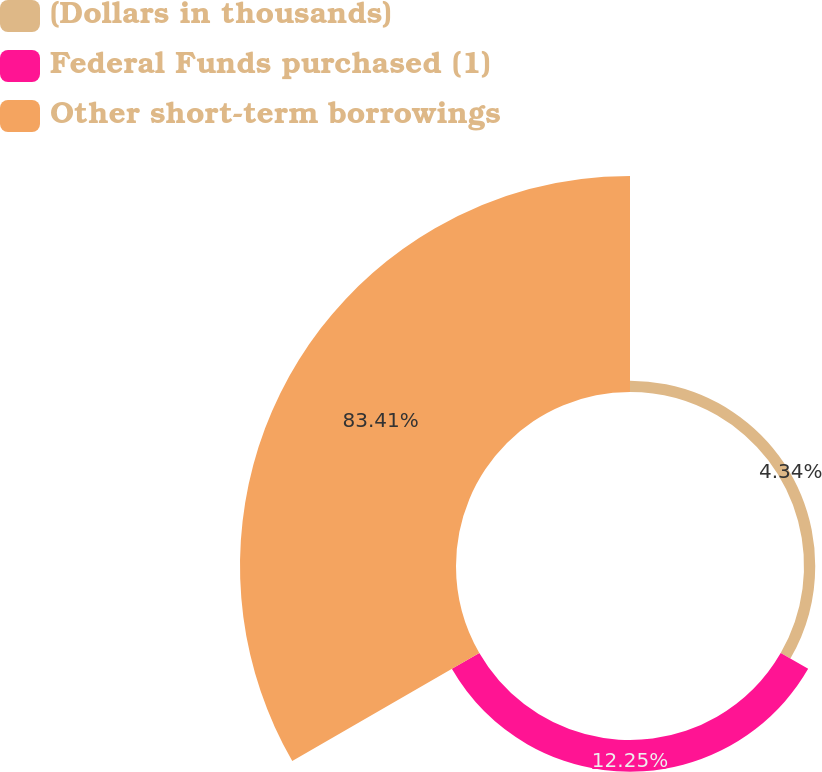Convert chart. <chart><loc_0><loc_0><loc_500><loc_500><pie_chart><fcel>(Dollars in thousands)<fcel>Federal Funds purchased (1)<fcel>Other short-term borrowings<nl><fcel>4.34%<fcel>12.25%<fcel>83.41%<nl></chart> 